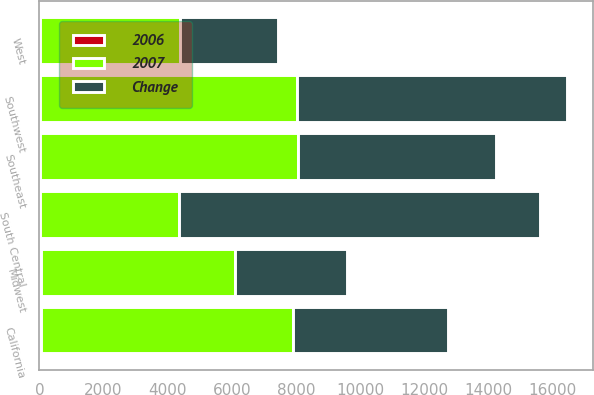Convert chart. <chart><loc_0><loc_0><loc_500><loc_500><stacked_bar_chart><ecel><fcel>Midwest<fcel>Southeast<fcel>South Central<fcel>Southwest<fcel>California<fcel>West<nl><fcel>Change<fcel>3502<fcel>6156<fcel>11260<fcel>8437<fcel>4817<fcel>3079<nl><fcel>2007<fcel>6050<fcel>8053<fcel>4341<fcel>8023<fcel>7884<fcel>4341<nl><fcel>2006<fcel>42<fcel>24<fcel>16<fcel>5<fcel>39<fcel>29<nl></chart> 